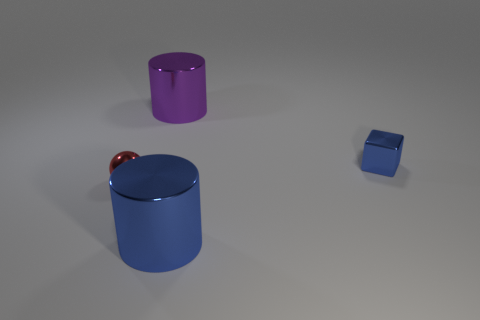Add 1 blue metallic cylinders. How many objects exist? 5 Subtract all blocks. How many objects are left? 3 Subtract 0 gray cubes. How many objects are left? 4 Subtract all big matte cubes. Subtract all tiny blue metal blocks. How many objects are left? 3 Add 2 big blue metal objects. How many big blue metal objects are left? 3 Add 3 blue metal cubes. How many blue metal cubes exist? 4 